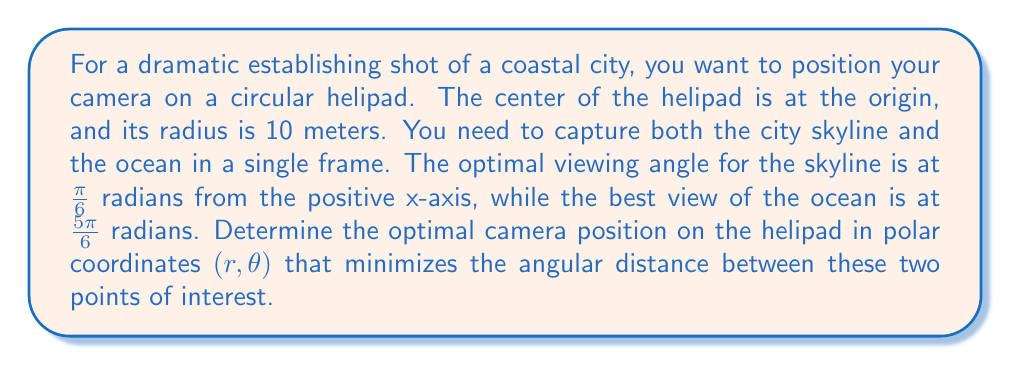Can you solve this math problem? To solve this problem, we'll follow these steps:

1) First, let's visualize the situation:

[asy]
unitsize(10cm);
draw(circle((0,0),1));
draw((-1.2,0)--(1.2,0),arrow=Arrow(TeXHead));
draw((0,-1.2)--(0,1.2),arrow=Arrow(TeXHead));
dot((cos(pi/6),sin(pi/6)),red);
dot((cos(5pi/6),sin(5pi/6)),blue);
label("Skyline",(cos(pi/6),sin(pi/6)),NE,red);
label("Ocean",(cos(5pi/6),sin(5pi/6)),NW,blue);
label("x",(-1.1,0),SW);
label("y",(0,1.1),NW);
[/asy]

2) The angular distance between the two points of interest is:

   $$\frac{5\pi}{6} - \frac{\pi}{6} = \frac{2\pi}{3}$$

3) To minimize the angular distance, the camera should be positioned exactly halfway between these two angles:

   $$\theta = \frac{\pi}{6} + \frac{1}{2}\left(\frac{5\pi}{6} - \frac{\pi}{6}\right) = \frac{\pi}{6} + \frac{\pi}{3} = \frac{\pi}{2}$$

4) This means the optimal angle is $\frac{\pi}{2}$ radians, or 90 degrees, from the positive x-axis.

5) Since the helipad is circular with a radius of 10 meters, the radial coordinate $r$ will always be 10.

6) Therefore, the optimal camera position in polar coordinates is $(10, \frac{\pi}{2})$.
Answer: $(10, \frac{\pi}{2})$ 